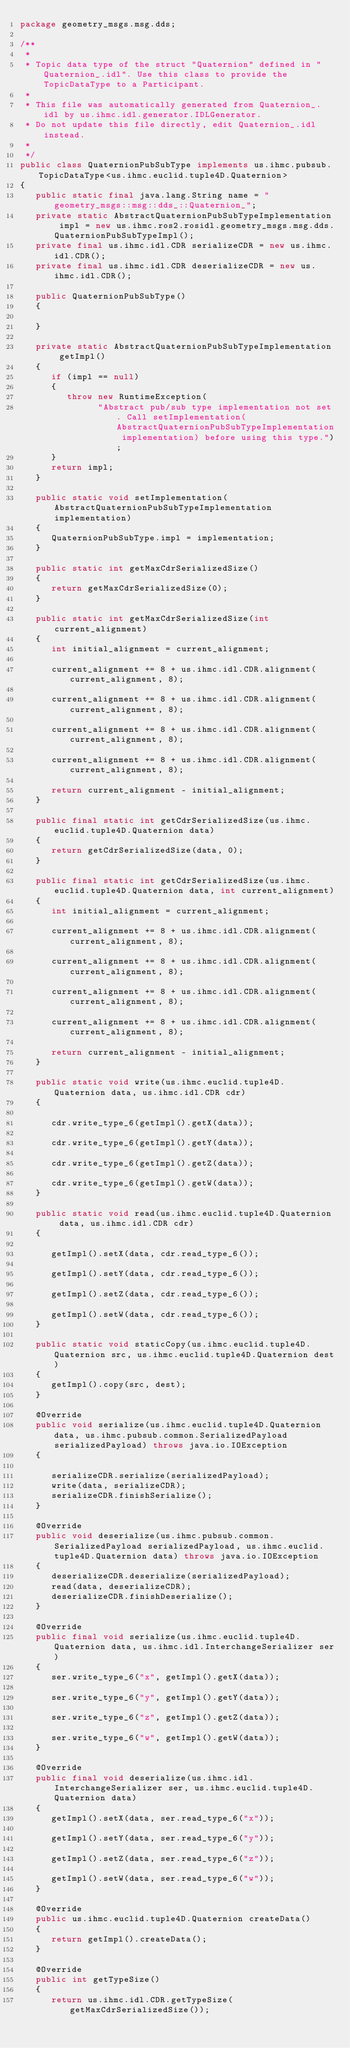Convert code to text. <code><loc_0><loc_0><loc_500><loc_500><_Java_>package geometry_msgs.msg.dds;

/**
 *
 * Topic data type of the struct "Quaternion" defined in "Quaternion_.idl". Use this class to provide the TopicDataType to a Participant.
 *
 * This file was automatically generated from Quaternion_.idl by us.ihmc.idl.generator.IDLGenerator.
 * Do not update this file directly, edit Quaternion_.idl instead.
 *
 */
public class QuaternionPubSubType implements us.ihmc.pubsub.TopicDataType<us.ihmc.euclid.tuple4D.Quaternion>
{
   public static final java.lang.String name = "geometry_msgs::msg::dds_::Quaternion_";
   private static AbstractQuaternionPubSubTypeImplementation impl = new us.ihmc.ros2.rosidl.geometry_msgs.msg.dds.QuaternionPubSubTypeImpl();
   private final us.ihmc.idl.CDR serializeCDR = new us.ihmc.idl.CDR();
   private final us.ihmc.idl.CDR deserializeCDR = new us.ihmc.idl.CDR();

   public QuaternionPubSubType()
   {

   }

   private static AbstractQuaternionPubSubTypeImplementation getImpl()
   {
      if (impl == null)
      {
         throw new RuntimeException(
               "Abstract pub/sub type implementation not set. Call setImplementation(AbstractQuaternionPubSubTypeImplementation implementation) before using this type.");
      }
      return impl;
   }

   public static void setImplementation(AbstractQuaternionPubSubTypeImplementation implementation)
   {
      QuaternionPubSubType.impl = implementation;
   }

   public static int getMaxCdrSerializedSize()
   {
      return getMaxCdrSerializedSize(0);
   }

   public static int getMaxCdrSerializedSize(int current_alignment)
   {
      int initial_alignment = current_alignment;

      current_alignment += 8 + us.ihmc.idl.CDR.alignment(current_alignment, 8);

      current_alignment += 8 + us.ihmc.idl.CDR.alignment(current_alignment, 8);

      current_alignment += 8 + us.ihmc.idl.CDR.alignment(current_alignment, 8);

      current_alignment += 8 + us.ihmc.idl.CDR.alignment(current_alignment, 8);

      return current_alignment - initial_alignment;
   }

   public final static int getCdrSerializedSize(us.ihmc.euclid.tuple4D.Quaternion data)
   {
      return getCdrSerializedSize(data, 0);
   }

   public final static int getCdrSerializedSize(us.ihmc.euclid.tuple4D.Quaternion data, int current_alignment)
   {
      int initial_alignment = current_alignment;

      current_alignment += 8 + us.ihmc.idl.CDR.alignment(current_alignment, 8);

      current_alignment += 8 + us.ihmc.idl.CDR.alignment(current_alignment, 8);

      current_alignment += 8 + us.ihmc.idl.CDR.alignment(current_alignment, 8);

      current_alignment += 8 + us.ihmc.idl.CDR.alignment(current_alignment, 8);

      return current_alignment - initial_alignment;
   }

   public static void write(us.ihmc.euclid.tuple4D.Quaternion data, us.ihmc.idl.CDR cdr)
   {

      cdr.write_type_6(getImpl().getX(data));

      cdr.write_type_6(getImpl().getY(data));

      cdr.write_type_6(getImpl().getZ(data));

      cdr.write_type_6(getImpl().getW(data));
   }

   public static void read(us.ihmc.euclid.tuple4D.Quaternion data, us.ihmc.idl.CDR cdr)
   {

      getImpl().setX(data, cdr.read_type_6());

      getImpl().setY(data, cdr.read_type_6());

      getImpl().setZ(data, cdr.read_type_6());

      getImpl().setW(data, cdr.read_type_6());
   }

   public static void staticCopy(us.ihmc.euclid.tuple4D.Quaternion src, us.ihmc.euclid.tuple4D.Quaternion dest)
   {
      getImpl().copy(src, dest);
   }

   @Override
   public void serialize(us.ihmc.euclid.tuple4D.Quaternion data, us.ihmc.pubsub.common.SerializedPayload serializedPayload) throws java.io.IOException
   {

      serializeCDR.serialize(serializedPayload);
      write(data, serializeCDR);
      serializeCDR.finishSerialize();
   }

   @Override
   public void deserialize(us.ihmc.pubsub.common.SerializedPayload serializedPayload, us.ihmc.euclid.tuple4D.Quaternion data) throws java.io.IOException
   {
      deserializeCDR.deserialize(serializedPayload);
      read(data, deserializeCDR);
      deserializeCDR.finishDeserialize();
   }

   @Override
   public final void serialize(us.ihmc.euclid.tuple4D.Quaternion data, us.ihmc.idl.InterchangeSerializer ser)
   {
      ser.write_type_6("x", getImpl().getX(data));

      ser.write_type_6("y", getImpl().getY(data));

      ser.write_type_6("z", getImpl().getZ(data));

      ser.write_type_6("w", getImpl().getW(data));
   }

   @Override
   public final void deserialize(us.ihmc.idl.InterchangeSerializer ser, us.ihmc.euclid.tuple4D.Quaternion data)
   {
      getImpl().setX(data, ser.read_type_6("x"));

      getImpl().setY(data, ser.read_type_6("y"));

      getImpl().setZ(data, ser.read_type_6("z"));

      getImpl().setW(data, ser.read_type_6("w"));
   }

   @Override
   public us.ihmc.euclid.tuple4D.Quaternion createData()
   {
      return getImpl().createData();
   }

   @Override
   public int getTypeSize()
   {
      return us.ihmc.idl.CDR.getTypeSize(getMaxCdrSerializedSize());</code> 